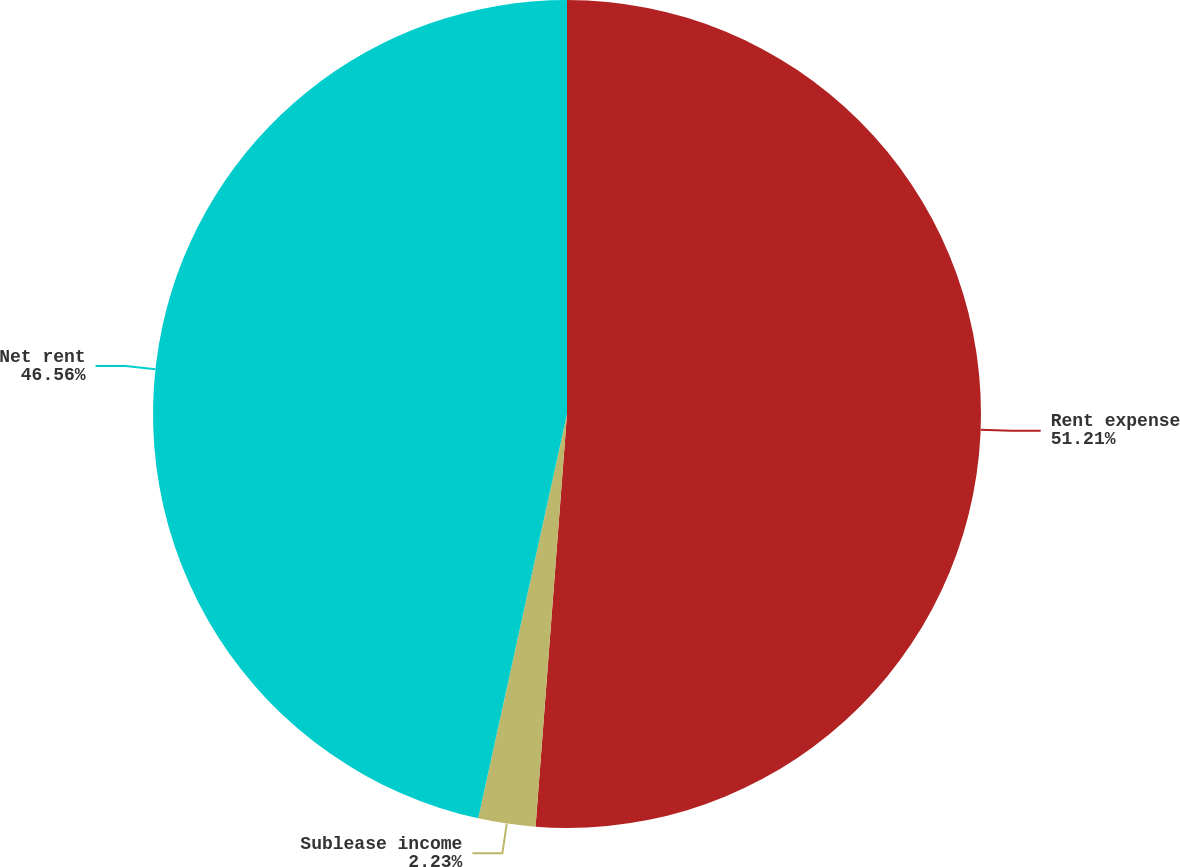<chart> <loc_0><loc_0><loc_500><loc_500><pie_chart><fcel>Rent expense<fcel>Sublease income<fcel>Net rent<nl><fcel>51.21%<fcel>2.23%<fcel>46.56%<nl></chart> 